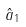Convert formula to latex. <formula><loc_0><loc_0><loc_500><loc_500>\hat { a } _ { 1 }</formula> 